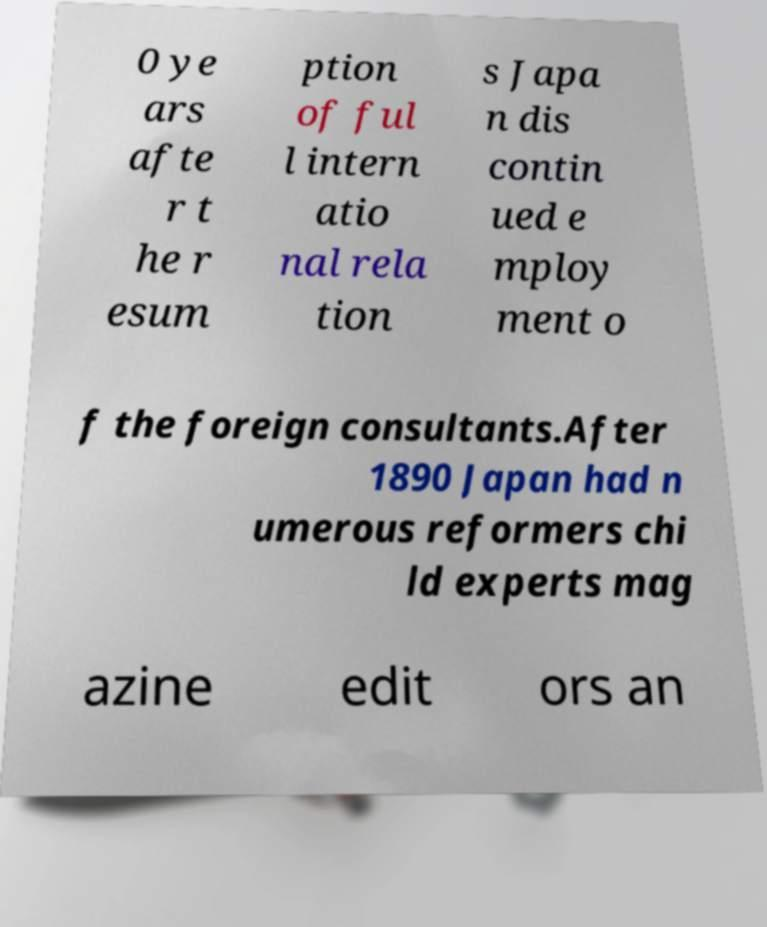Please identify and transcribe the text found in this image. 0 ye ars afte r t he r esum ption of ful l intern atio nal rela tion s Japa n dis contin ued e mploy ment o f the foreign consultants.After 1890 Japan had n umerous reformers chi ld experts mag azine edit ors an 